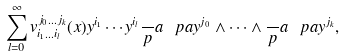<formula> <loc_0><loc_0><loc_500><loc_500>\sum _ { l = 0 } ^ { \infty } v _ { i _ { 1 } \dots i _ { l } } ^ { j _ { 0 } \dots j _ { k } } ( x ) y ^ { i _ { 1 } } \cdots y ^ { i _ { l } } \frac { \ } { p } a { \ p a y ^ { j _ { 0 } } } \wedge \cdots \wedge \frac { \ } { p } a { \ p a y ^ { j _ { k } } } ,</formula> 